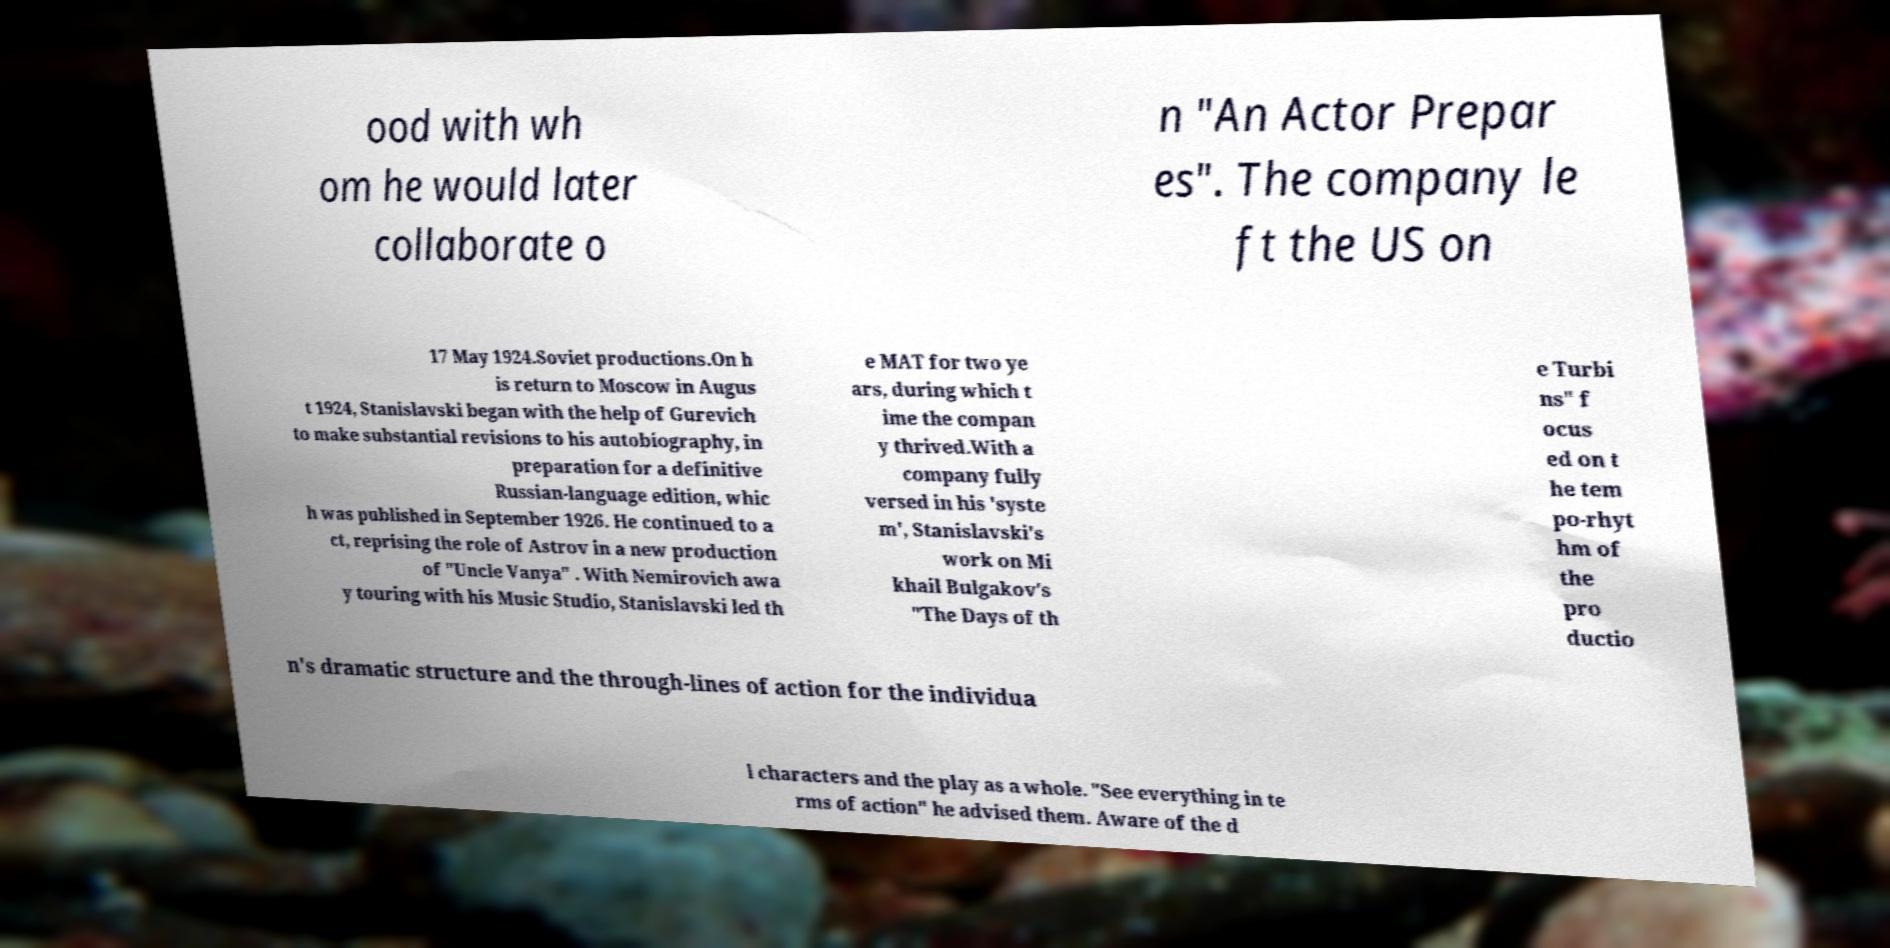Please identify and transcribe the text found in this image. ood with wh om he would later collaborate o n "An Actor Prepar es". The company le ft the US on 17 May 1924.Soviet productions.On h is return to Moscow in Augus t 1924, Stanislavski began with the help of Gurevich to make substantial revisions to his autobiography, in preparation for a definitive Russian-language edition, whic h was published in September 1926. He continued to a ct, reprising the role of Astrov in a new production of "Uncle Vanya" . With Nemirovich awa y touring with his Music Studio, Stanislavski led th e MAT for two ye ars, during which t ime the compan y thrived.With a company fully versed in his 'syste m', Stanislavski's work on Mi khail Bulgakov's "The Days of th e Turbi ns" f ocus ed on t he tem po-rhyt hm of the pro ductio n's dramatic structure and the through-lines of action for the individua l characters and the play as a whole. "See everything in te rms of action" he advised them. Aware of the d 